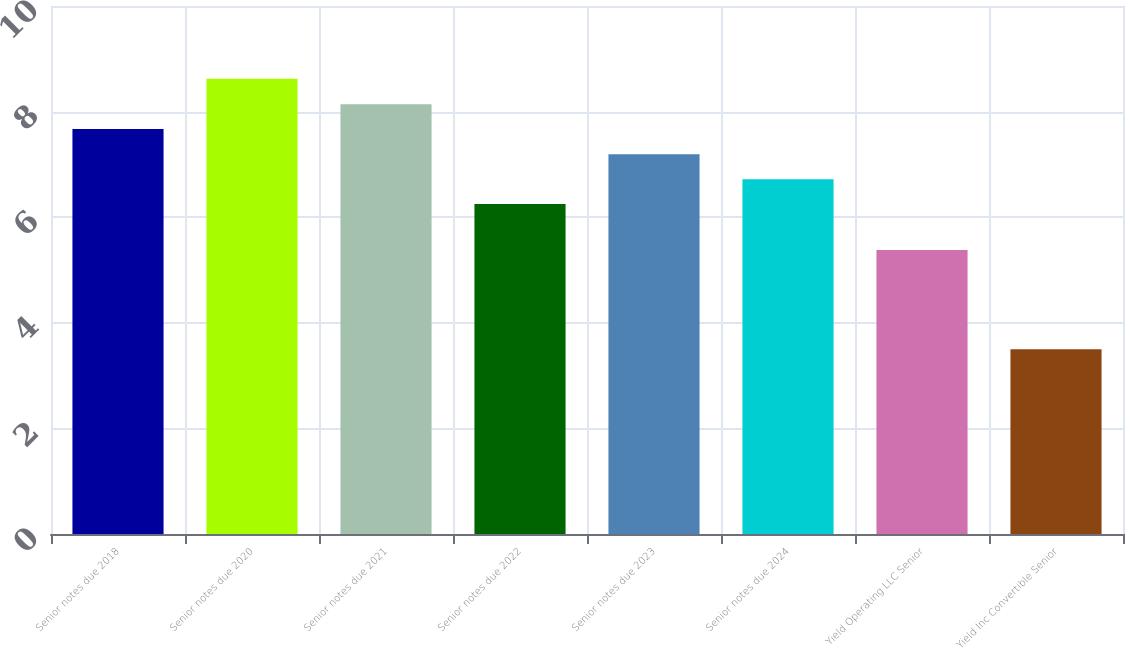Convert chart to OTSL. <chart><loc_0><loc_0><loc_500><loc_500><bar_chart><fcel>Senior notes due 2018<fcel>Senior notes due 2020<fcel>Senior notes due 2021<fcel>Senior notes due 2022<fcel>Senior notes due 2023<fcel>Senior notes due 2024<fcel>Yield Operating LLC Senior<fcel>Yield Inc Convertible Senior<nl><fcel>7.67<fcel>8.62<fcel>8.14<fcel>6.25<fcel>7.19<fcel>6.72<fcel>5.38<fcel>3.5<nl></chart> 